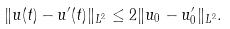<formula> <loc_0><loc_0><loc_500><loc_500>\| u ( t ) - u ^ { \prime } ( t ) \| _ { L ^ { 2 } } \leq 2 \| u _ { 0 } - u _ { 0 } ^ { \prime } \| _ { L ^ { 2 } } .</formula> 